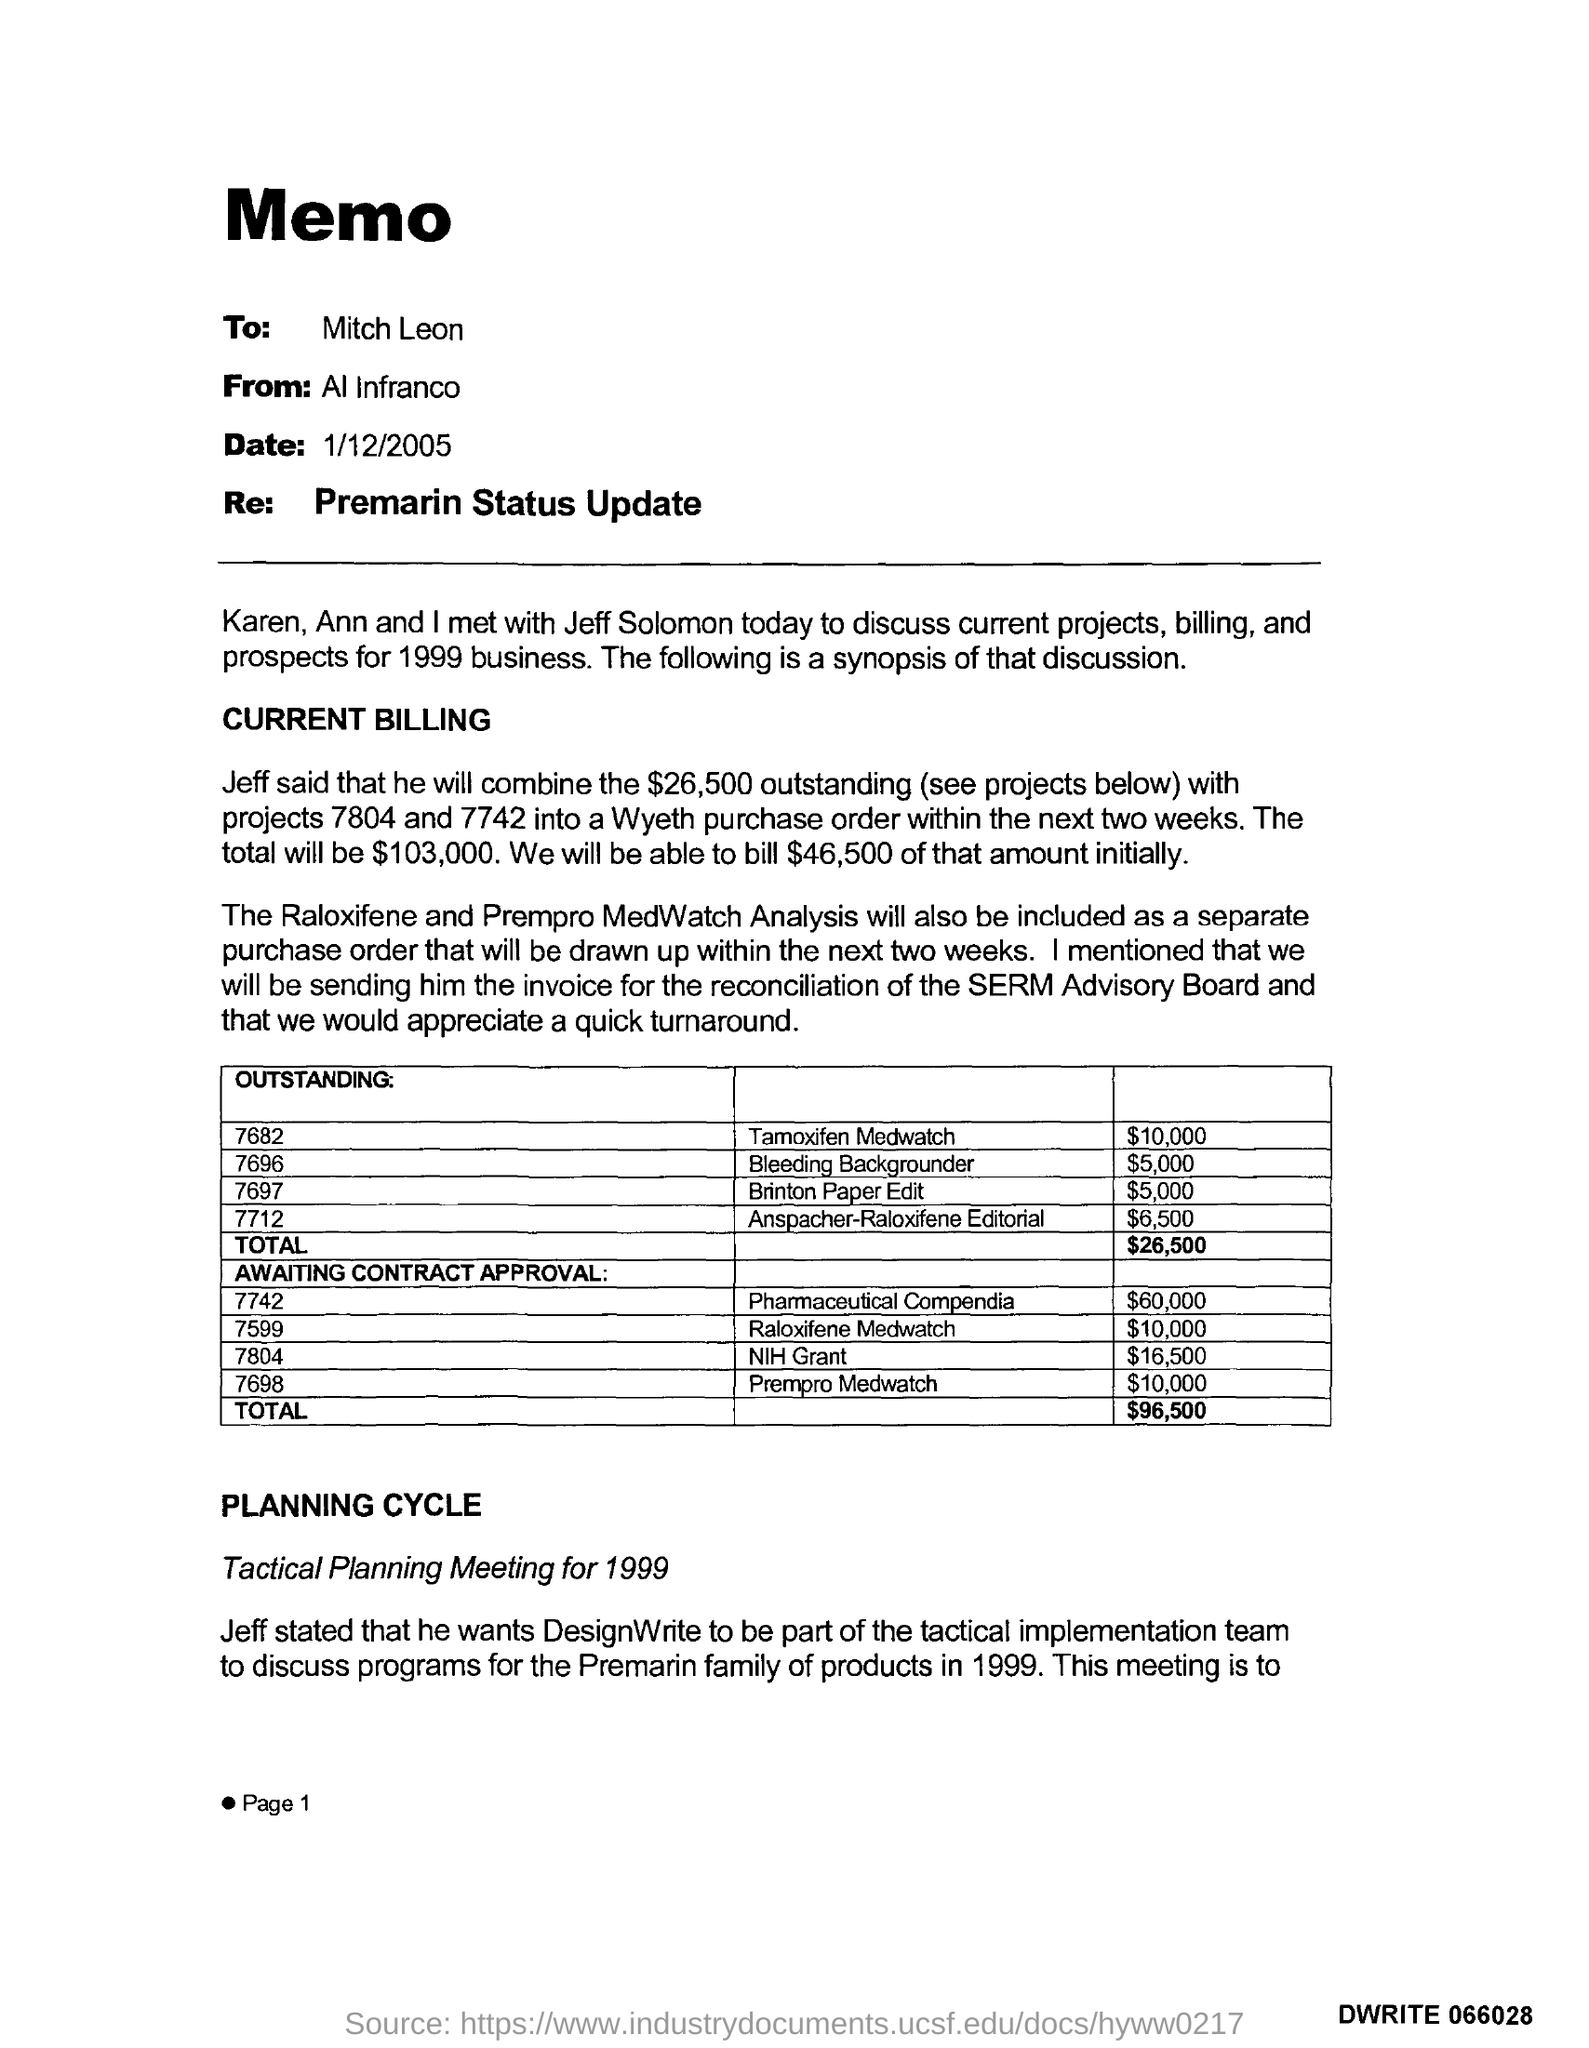What is the date?
Provide a short and direct response. 1/12/2005. What is the page number?
Provide a short and direct response. 1. 